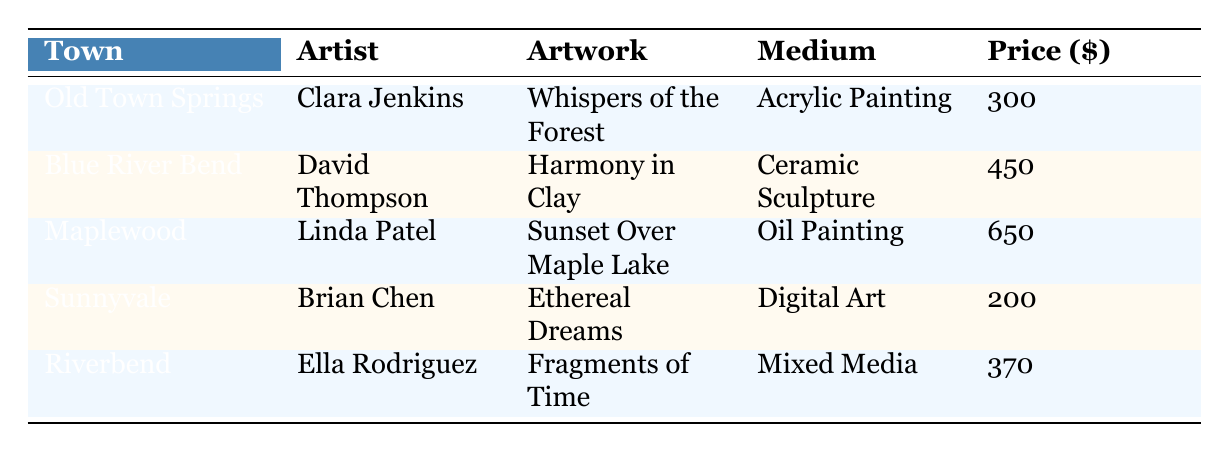What is the title of David Thompson's artwork? The table shows that David Thompson's artwork is located under the artist name in the row for Blue River Bend. The title listed is "Harmony in Clay."
Answer: Harmony in Clay Which artist sold their artwork for the highest price? By examining the sale prices in the table, Linda Patel from Maplewood has the highest sale price of 650 dollars for "Sunset Over Maple Lake."
Answer: Linda Patel What is the total sale price of all artworks listed in the table? To find the total sale price, we sum the prices: 300 + 450 + 650 + 200 + 370 = 1970. Therefore, the total is 1970 dollars.
Answer: 1970 Did any artwork sell for less than 250 dollars? In the table, only Brian Chen's artwork sold for 200 dollars, which is below 250 dollars. Thus, the answer is yes.
Answer: Yes What is the difference in sale price between the most expensive and least expensive artworks? The most expensive artwork is Linda Patel's at 650 dollars, and the least expensive is Brian Chen's at 200 dollars. The difference is calculated as 650 - 200 = 450.
Answer: 450 How many different mediums are represented in the sales data? The table lists five artworks with four distinct mediums: Acrylic Painting, Ceramic Sculpture, Oil Painting, Digital Art, and Mixed Media. Hence, there are five different mediums represented.
Answer: 5 